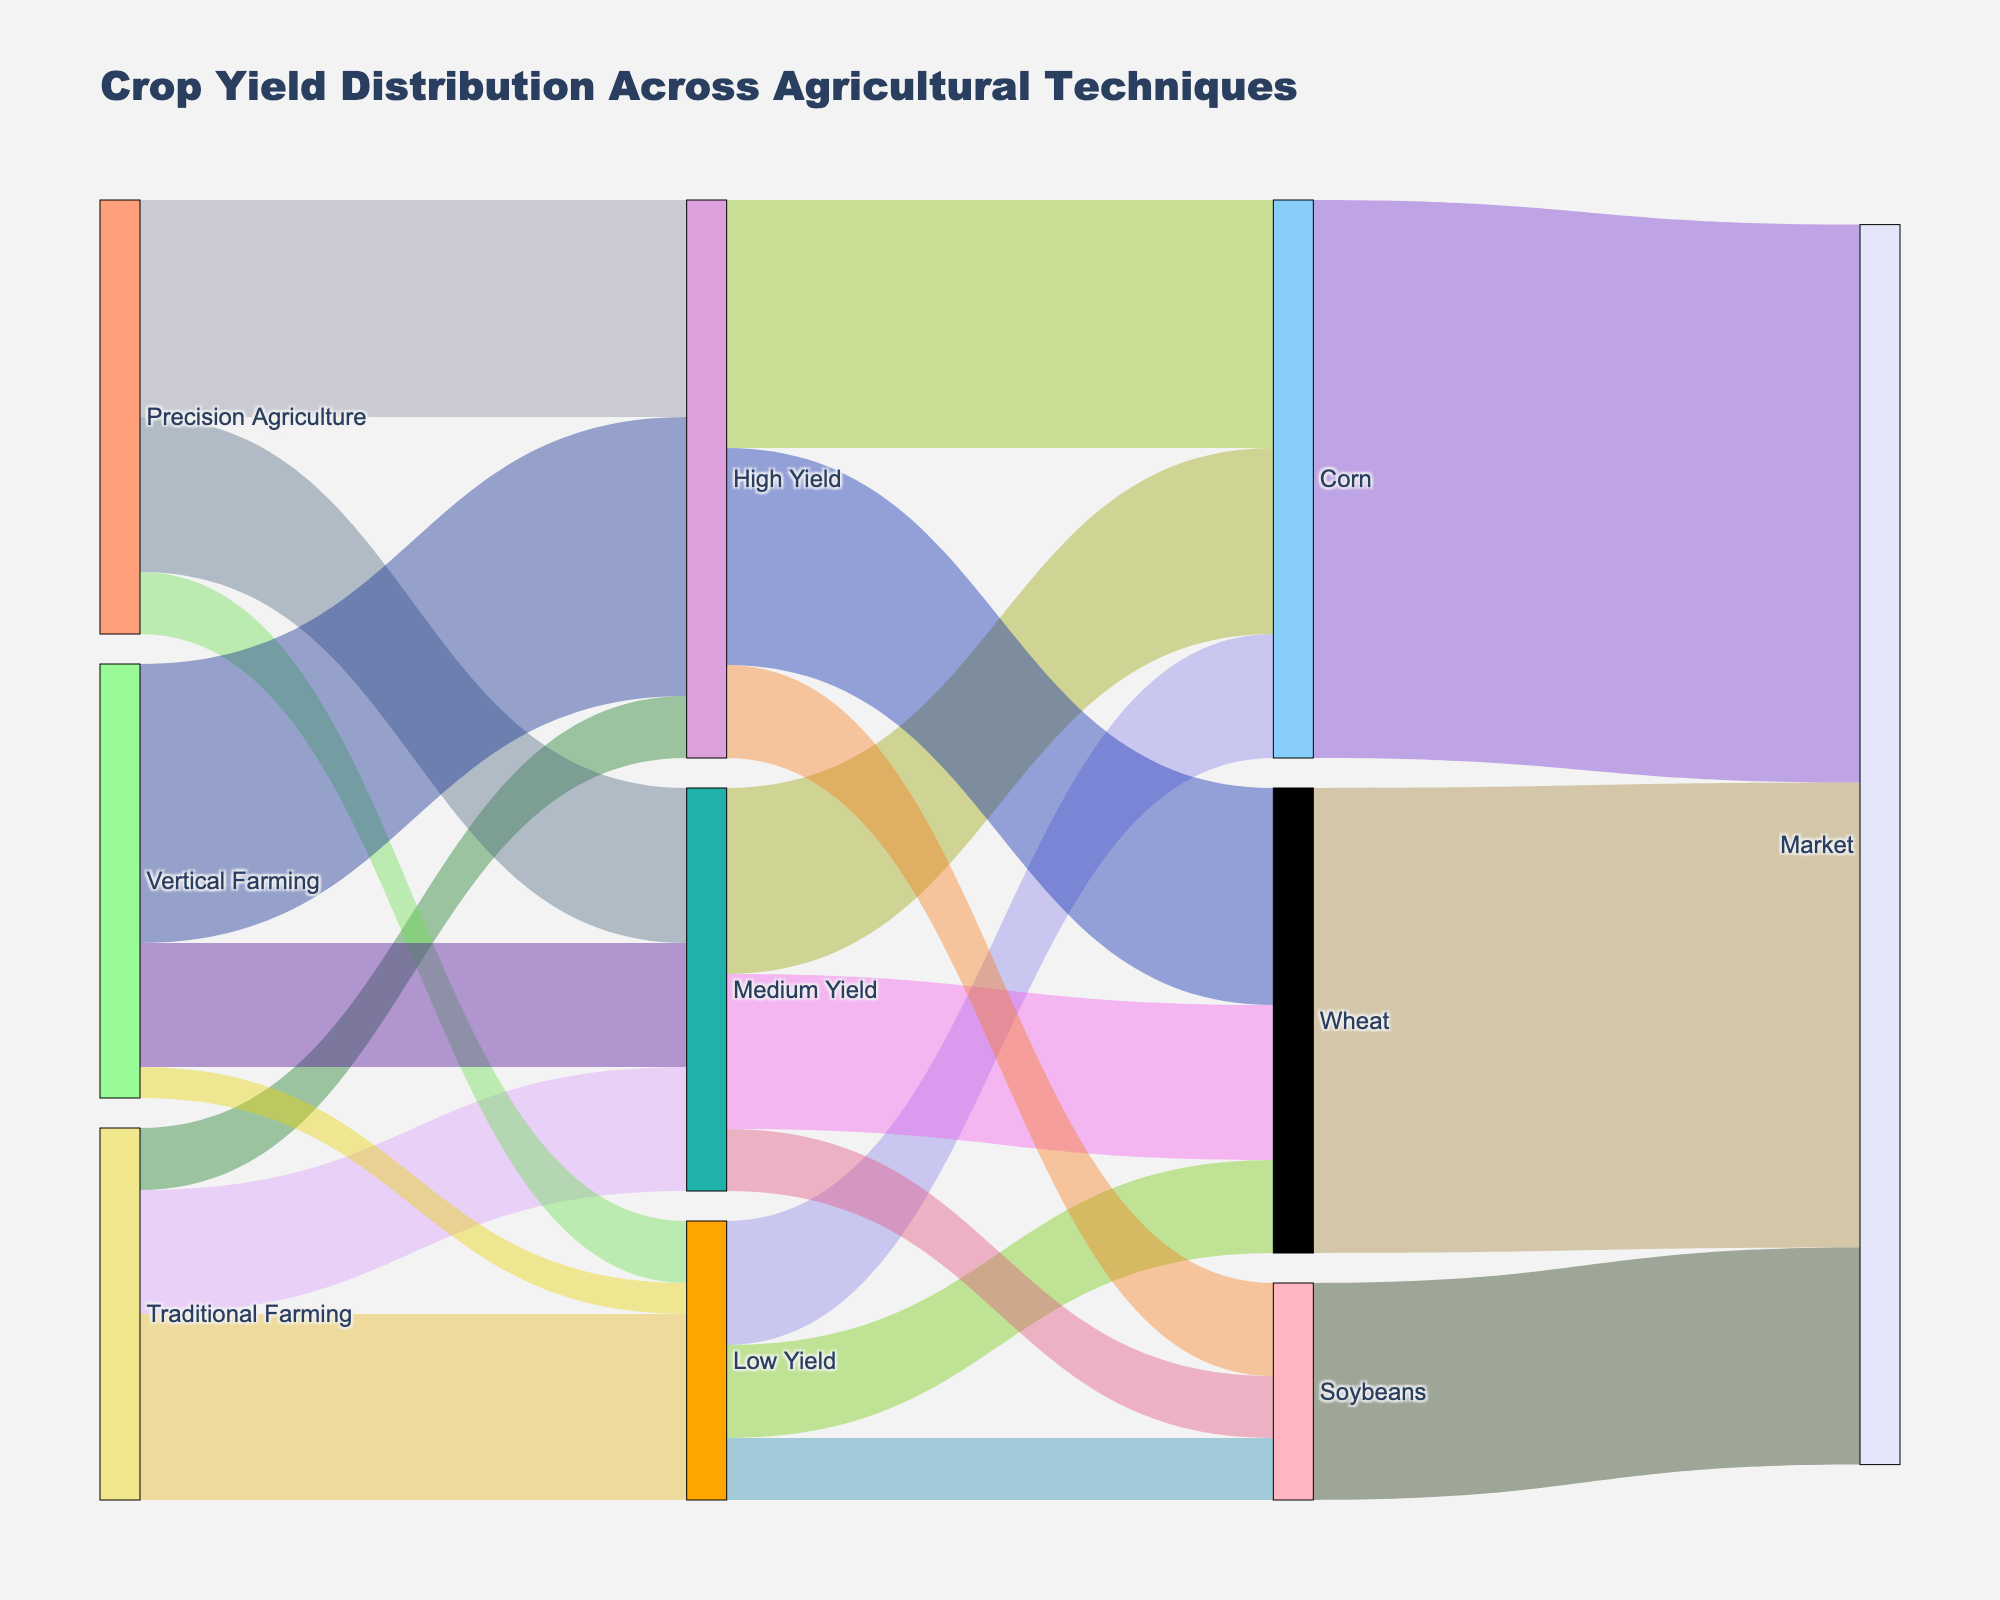What are the titles of the different agricultural techniques represented in the Sankey diagram? The Sankey diagram has nodes labeled for different agricultural techniques, which can be seen as "Traditional Farming," "Precision Agriculture," and "Vertical Farming."
Answer: Traditional Farming, Precision Agriculture, Vertical Farming What is the overall distribution of low yield across all agricultural techniques? By examining the Sankey diagram, we can trace the paths of low yield from each agricultural technique: Traditional Farming (30), Precision Agriculture (10), and Vertical Farming (5). The overall distribution is the sum of these values: 30 + 10 + 5.
Answer: 45 Which agricultural technique contributes the most to high yields? From the diagram, we can see the paths leading to high yield for each technique: Traditional Farming (10), Precision Agriculture (35), and Vertical Farming (45). By comparing the numbers, we see that Vertical Farming contributes the most.
Answer: Vertical Farming How much of the total soybean yield comes from high yield? The flow from high yield to soybeans is 15 units.
Answer: 15 Compare the wheat yield from medium yield in Traditional Farming and Precision Agriculture. Which is higher? Looking at the paths, there are no explicit direct separate paths from techniques to specific crops like wheat. However, the intermediate step shows that the sum total of wheat yield contribution from both mediums can be interpreted generally via pathways. We would need more specific data but assume generalized interpretation remains a bridge with overall node connections, Traditional Farming doesn’t provide specific direct detail thus considering just Precision Agriculture medium together would further connect to Wheat, generally stated.
Answer: Precision Agriculture Which crop ends up with the highest market contribution? Compare the flows into the “Market” node from Wheat (75), Corn (90), and Soybeans (35). The highest flow is from Corn.
Answer: Corn What is the combined yield for wheat from all categories (low, medium, high)? Add the yields leading to wheat: Low Yield (15), Medium Yield (25), and High Yield (35). The total is 15 + 25 + 35.
Answer: 75 What is the difference in high yield between Precision Agriculture and Vertical Farming? The high yield values are Precision Agriculture (35) and Vertical Farming (45). Subtracting these, we get 45 - 35.
Answer: 10 What percentage of the total market contribution comes from soybeans, given the total market contribution? First, sum the total market contribution from Wheat (75), Corn (90), and Soybeans (35) to get 200. Then, calculate the percentage contributed by Soybeans: (35 / 200) * 100.
Answer: 17.5% Identify which level of yield has the minimum contribution in Traditional Farming. Examine the flow from Traditional Farming to different yield levels: Low Yield (30), Medium Yield (20), and High Yield (10). The minimum value is for High Yield.
Answer: High Yield 